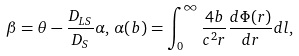<formula> <loc_0><loc_0><loc_500><loc_500>\beta = \theta - \frac { D _ { L S } } { D _ { S } } \alpha , \, \alpha ( b ) = \int _ { 0 } ^ { \infty } \frac { 4 b } { c ^ { 2 } r } \frac { d \Phi ( r ) } { d r } d l ,</formula> 